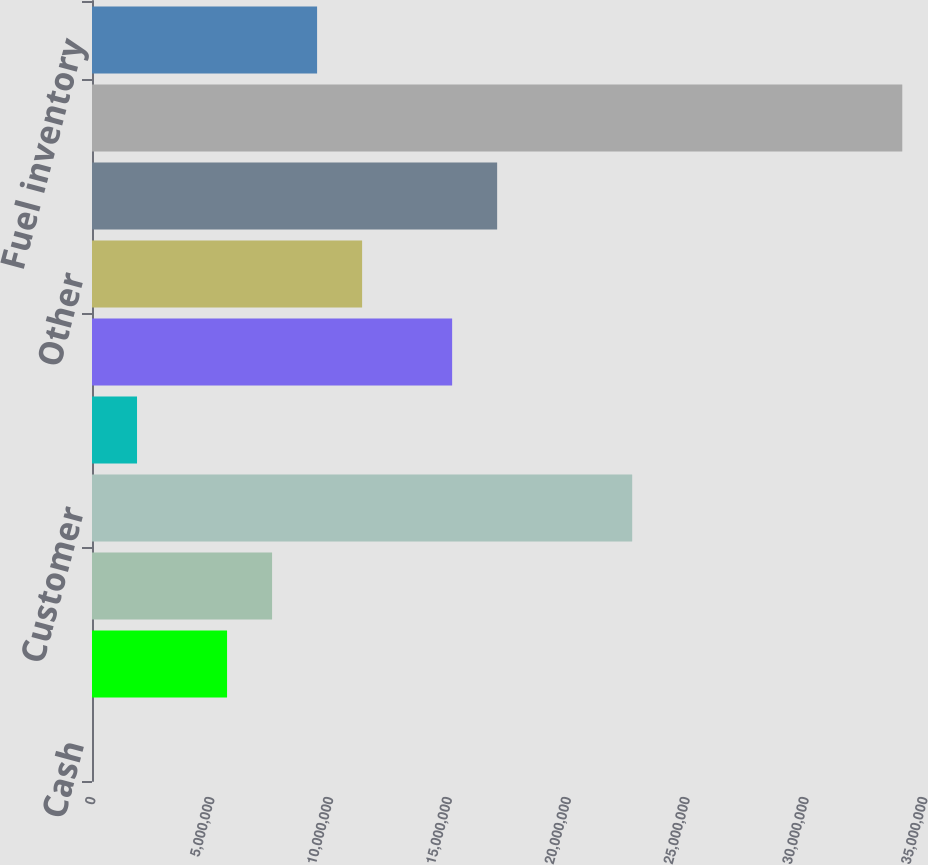Convert chart to OTSL. <chart><loc_0><loc_0><loc_500><loc_500><bar_chart><fcel>Cash<fcel>Temporary cash investments<fcel>Total cash and cash<fcel>Customer<fcel>Allowance for doubtful<fcel>Associated companies<fcel>Other<fcel>Accrued unbilled revenues<fcel>Total accounts receivable<fcel>Fuel inventory<nl><fcel>348<fcel>5.68142e+06<fcel>7.57511e+06<fcel>2.27246e+07<fcel>1.89404e+06<fcel>1.51499e+07<fcel>1.13625e+07<fcel>1.70436e+07<fcel>3.40868e+07<fcel>9.46879e+06<nl></chart> 